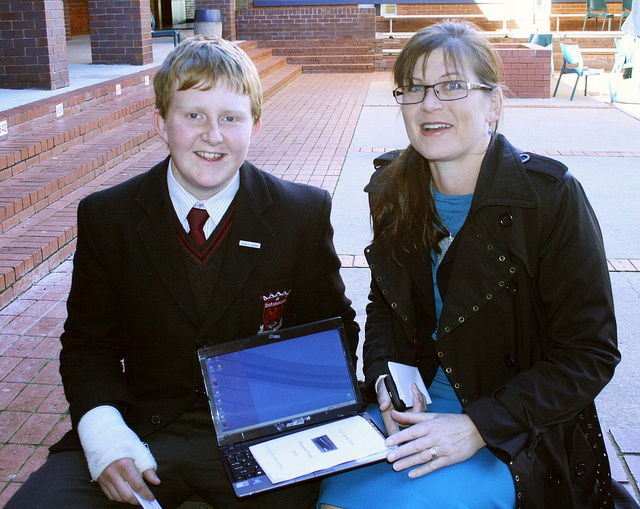Describe the objects in this image and their specific colors. I can see people in purple, black, darkgray, lavender, and blue tones, people in purple, black, lavender, darkgray, and gray tones, laptop in purple, white, blue, and black tones, chair in purple, white, lightblue, tan, and gray tones, and chair in purple, teal, darkgray, and tan tones in this image. 